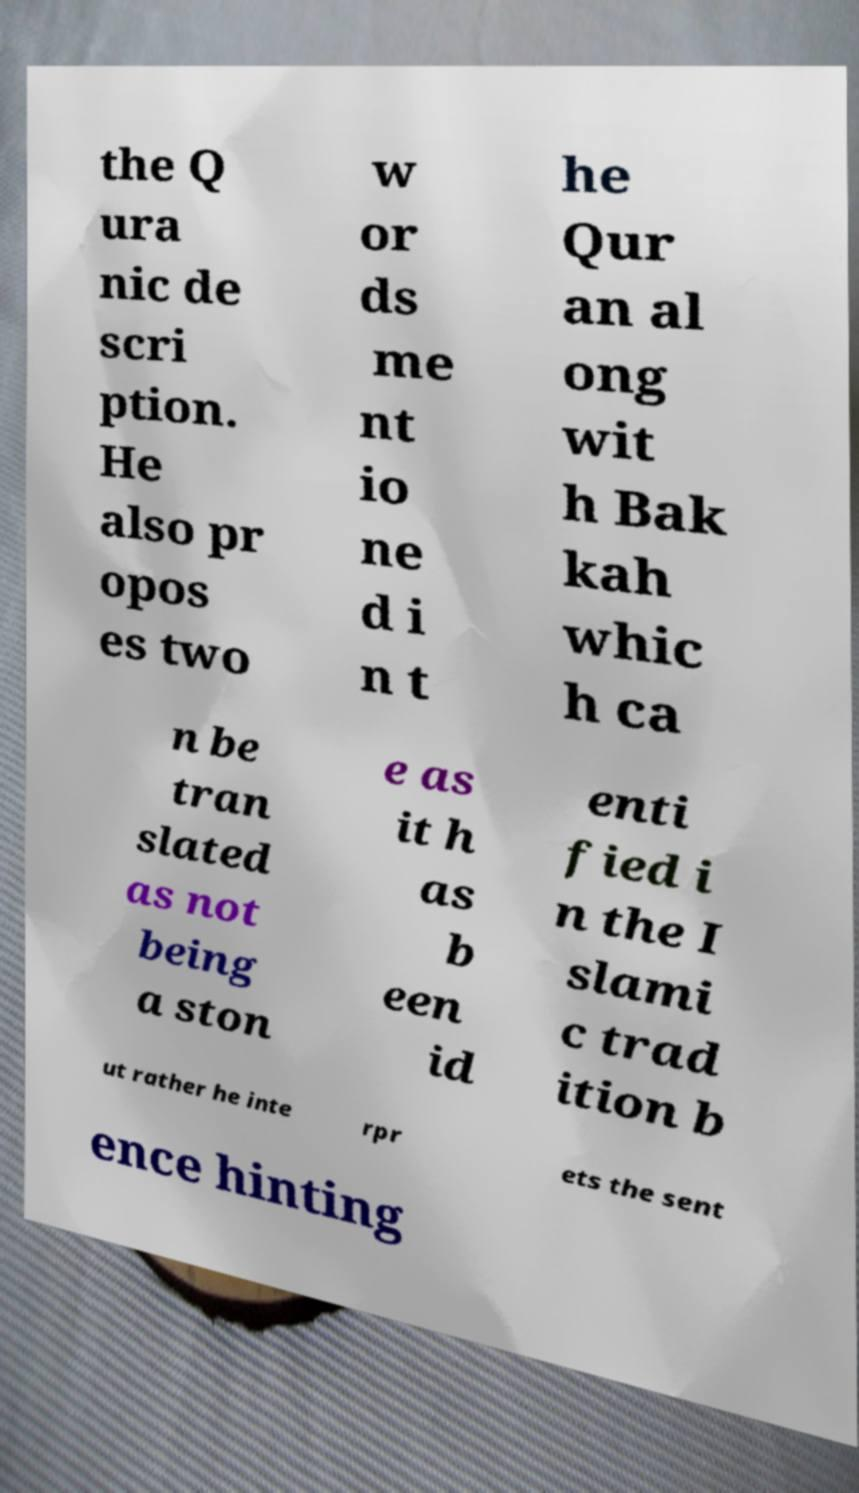Please identify and transcribe the text found in this image. the Q ura nic de scri ption. He also pr opos es two w or ds me nt io ne d i n t he Qur an al ong wit h Bak kah whic h ca n be tran slated as not being a ston e as it h as b een id enti fied i n the I slami c trad ition b ut rather he inte rpr ets the sent ence hinting 